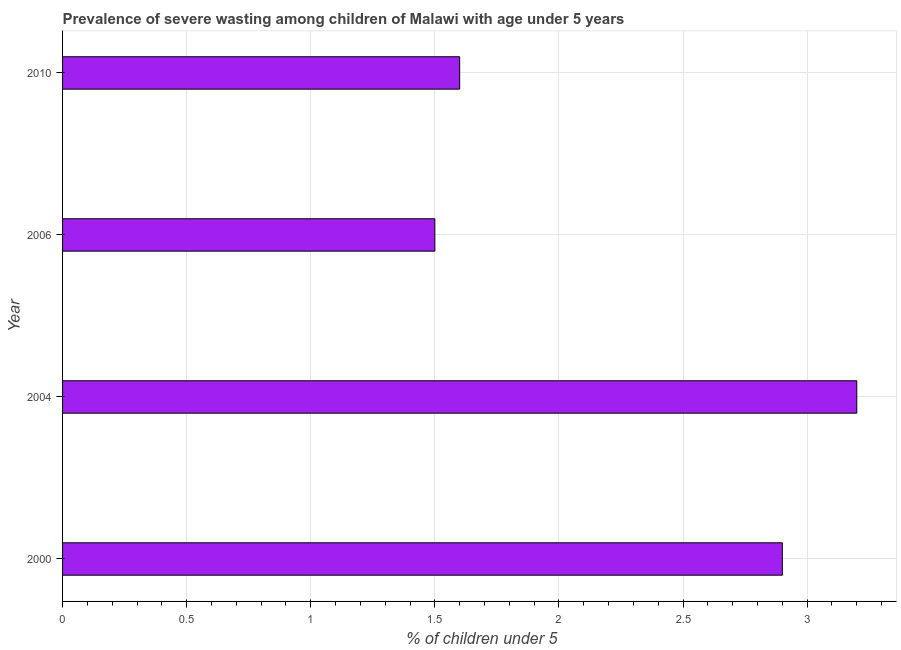Does the graph contain any zero values?
Your response must be concise. No. Does the graph contain grids?
Provide a succinct answer. Yes. What is the title of the graph?
Your response must be concise. Prevalence of severe wasting among children of Malawi with age under 5 years. What is the label or title of the X-axis?
Your answer should be compact.  % of children under 5. What is the prevalence of severe wasting in 2000?
Ensure brevity in your answer.  2.9. Across all years, what is the maximum prevalence of severe wasting?
Your answer should be very brief. 3.2. Across all years, what is the minimum prevalence of severe wasting?
Offer a terse response. 1.5. In which year was the prevalence of severe wasting maximum?
Your response must be concise. 2004. What is the sum of the prevalence of severe wasting?
Your response must be concise. 9.2. What is the difference between the prevalence of severe wasting in 2000 and 2004?
Ensure brevity in your answer.  -0.3. What is the median prevalence of severe wasting?
Give a very brief answer. 2.25. In how many years, is the prevalence of severe wasting greater than 1.2 %?
Offer a terse response. 4. What is the ratio of the prevalence of severe wasting in 2000 to that in 2006?
Your response must be concise. 1.93. Is the sum of the prevalence of severe wasting in 2004 and 2006 greater than the maximum prevalence of severe wasting across all years?
Make the answer very short. Yes. What is the difference between the highest and the lowest prevalence of severe wasting?
Provide a short and direct response. 1.7. Are all the bars in the graph horizontal?
Your response must be concise. Yes. Are the values on the major ticks of X-axis written in scientific E-notation?
Ensure brevity in your answer.  No. What is the  % of children under 5 in 2000?
Make the answer very short. 2.9. What is the  % of children under 5 of 2004?
Offer a very short reply. 3.2. What is the  % of children under 5 in 2006?
Offer a terse response. 1.5. What is the  % of children under 5 of 2010?
Offer a terse response. 1.6. What is the difference between the  % of children under 5 in 2000 and 2010?
Make the answer very short. 1.3. What is the difference between the  % of children under 5 in 2004 and 2006?
Keep it short and to the point. 1.7. What is the difference between the  % of children under 5 in 2004 and 2010?
Offer a very short reply. 1.6. What is the ratio of the  % of children under 5 in 2000 to that in 2004?
Your response must be concise. 0.91. What is the ratio of the  % of children under 5 in 2000 to that in 2006?
Your answer should be very brief. 1.93. What is the ratio of the  % of children under 5 in 2000 to that in 2010?
Your answer should be compact. 1.81. What is the ratio of the  % of children under 5 in 2004 to that in 2006?
Ensure brevity in your answer.  2.13. What is the ratio of the  % of children under 5 in 2006 to that in 2010?
Your answer should be compact. 0.94. 